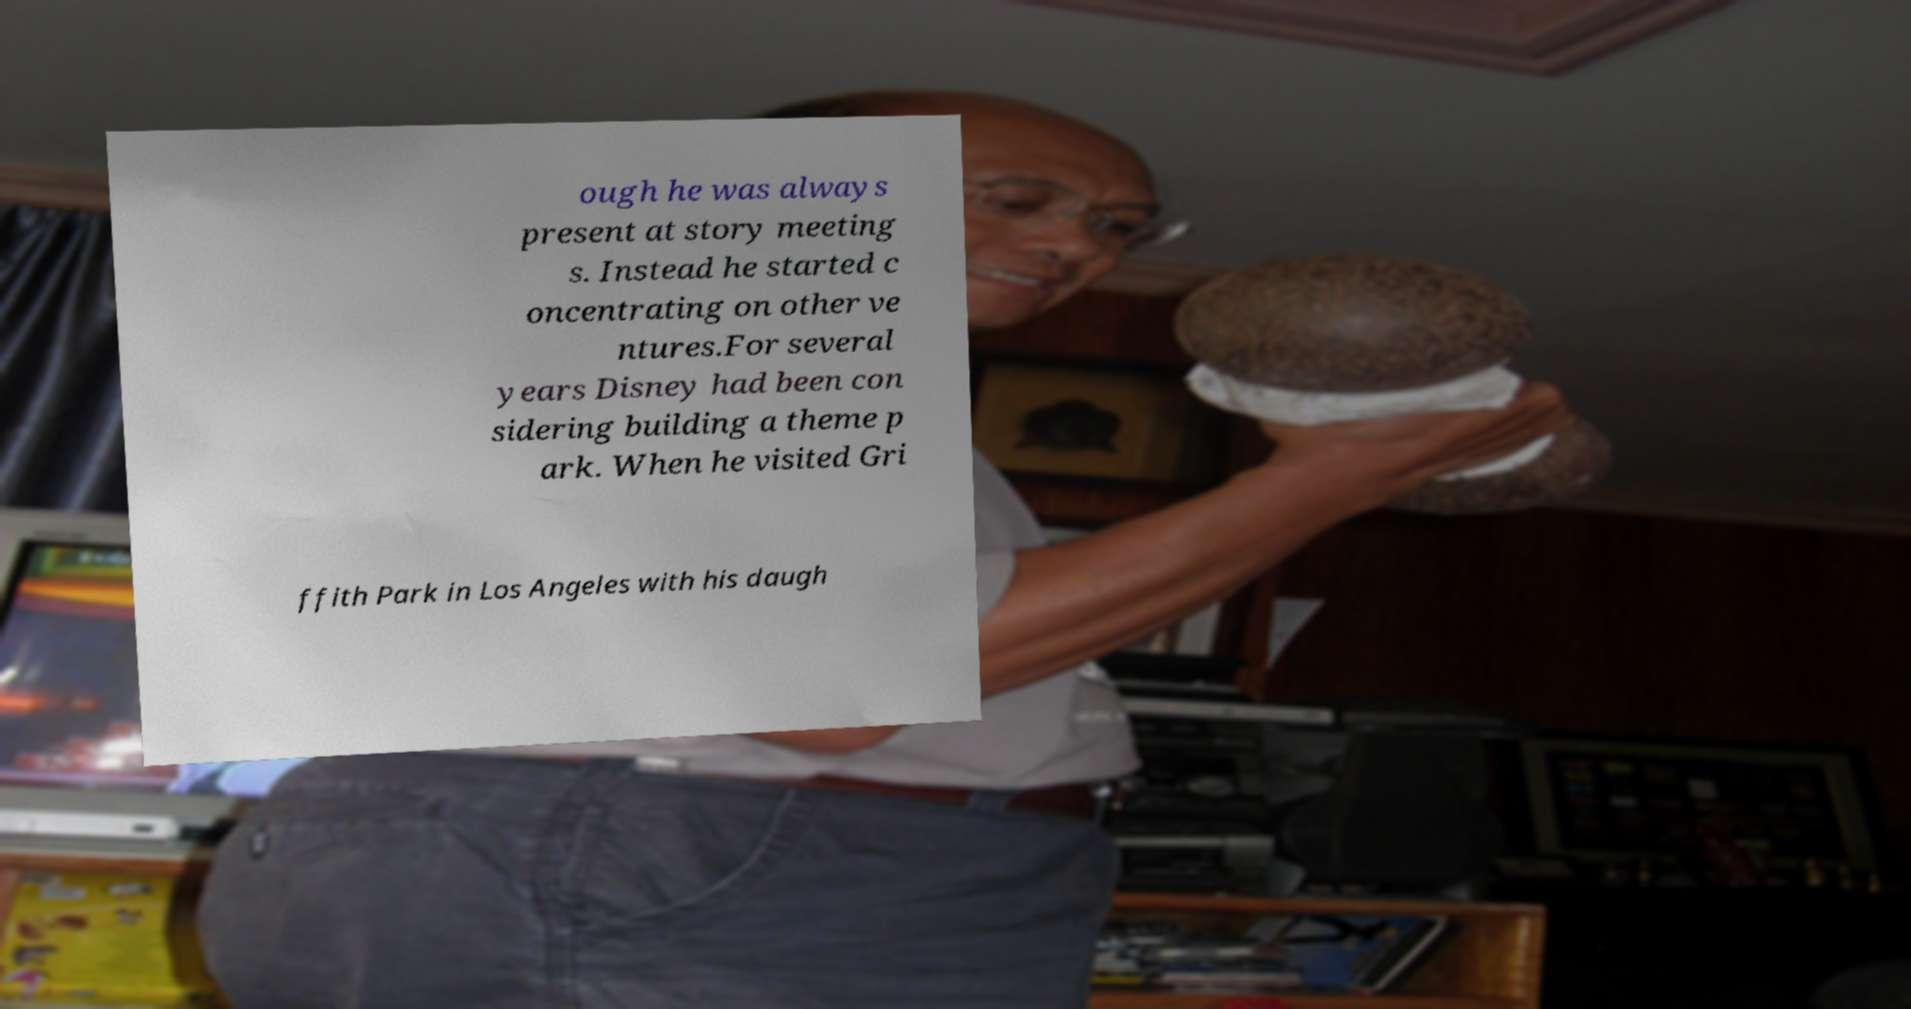Could you assist in decoding the text presented in this image and type it out clearly? ough he was always present at story meeting s. Instead he started c oncentrating on other ve ntures.For several years Disney had been con sidering building a theme p ark. When he visited Gri ffith Park in Los Angeles with his daugh 